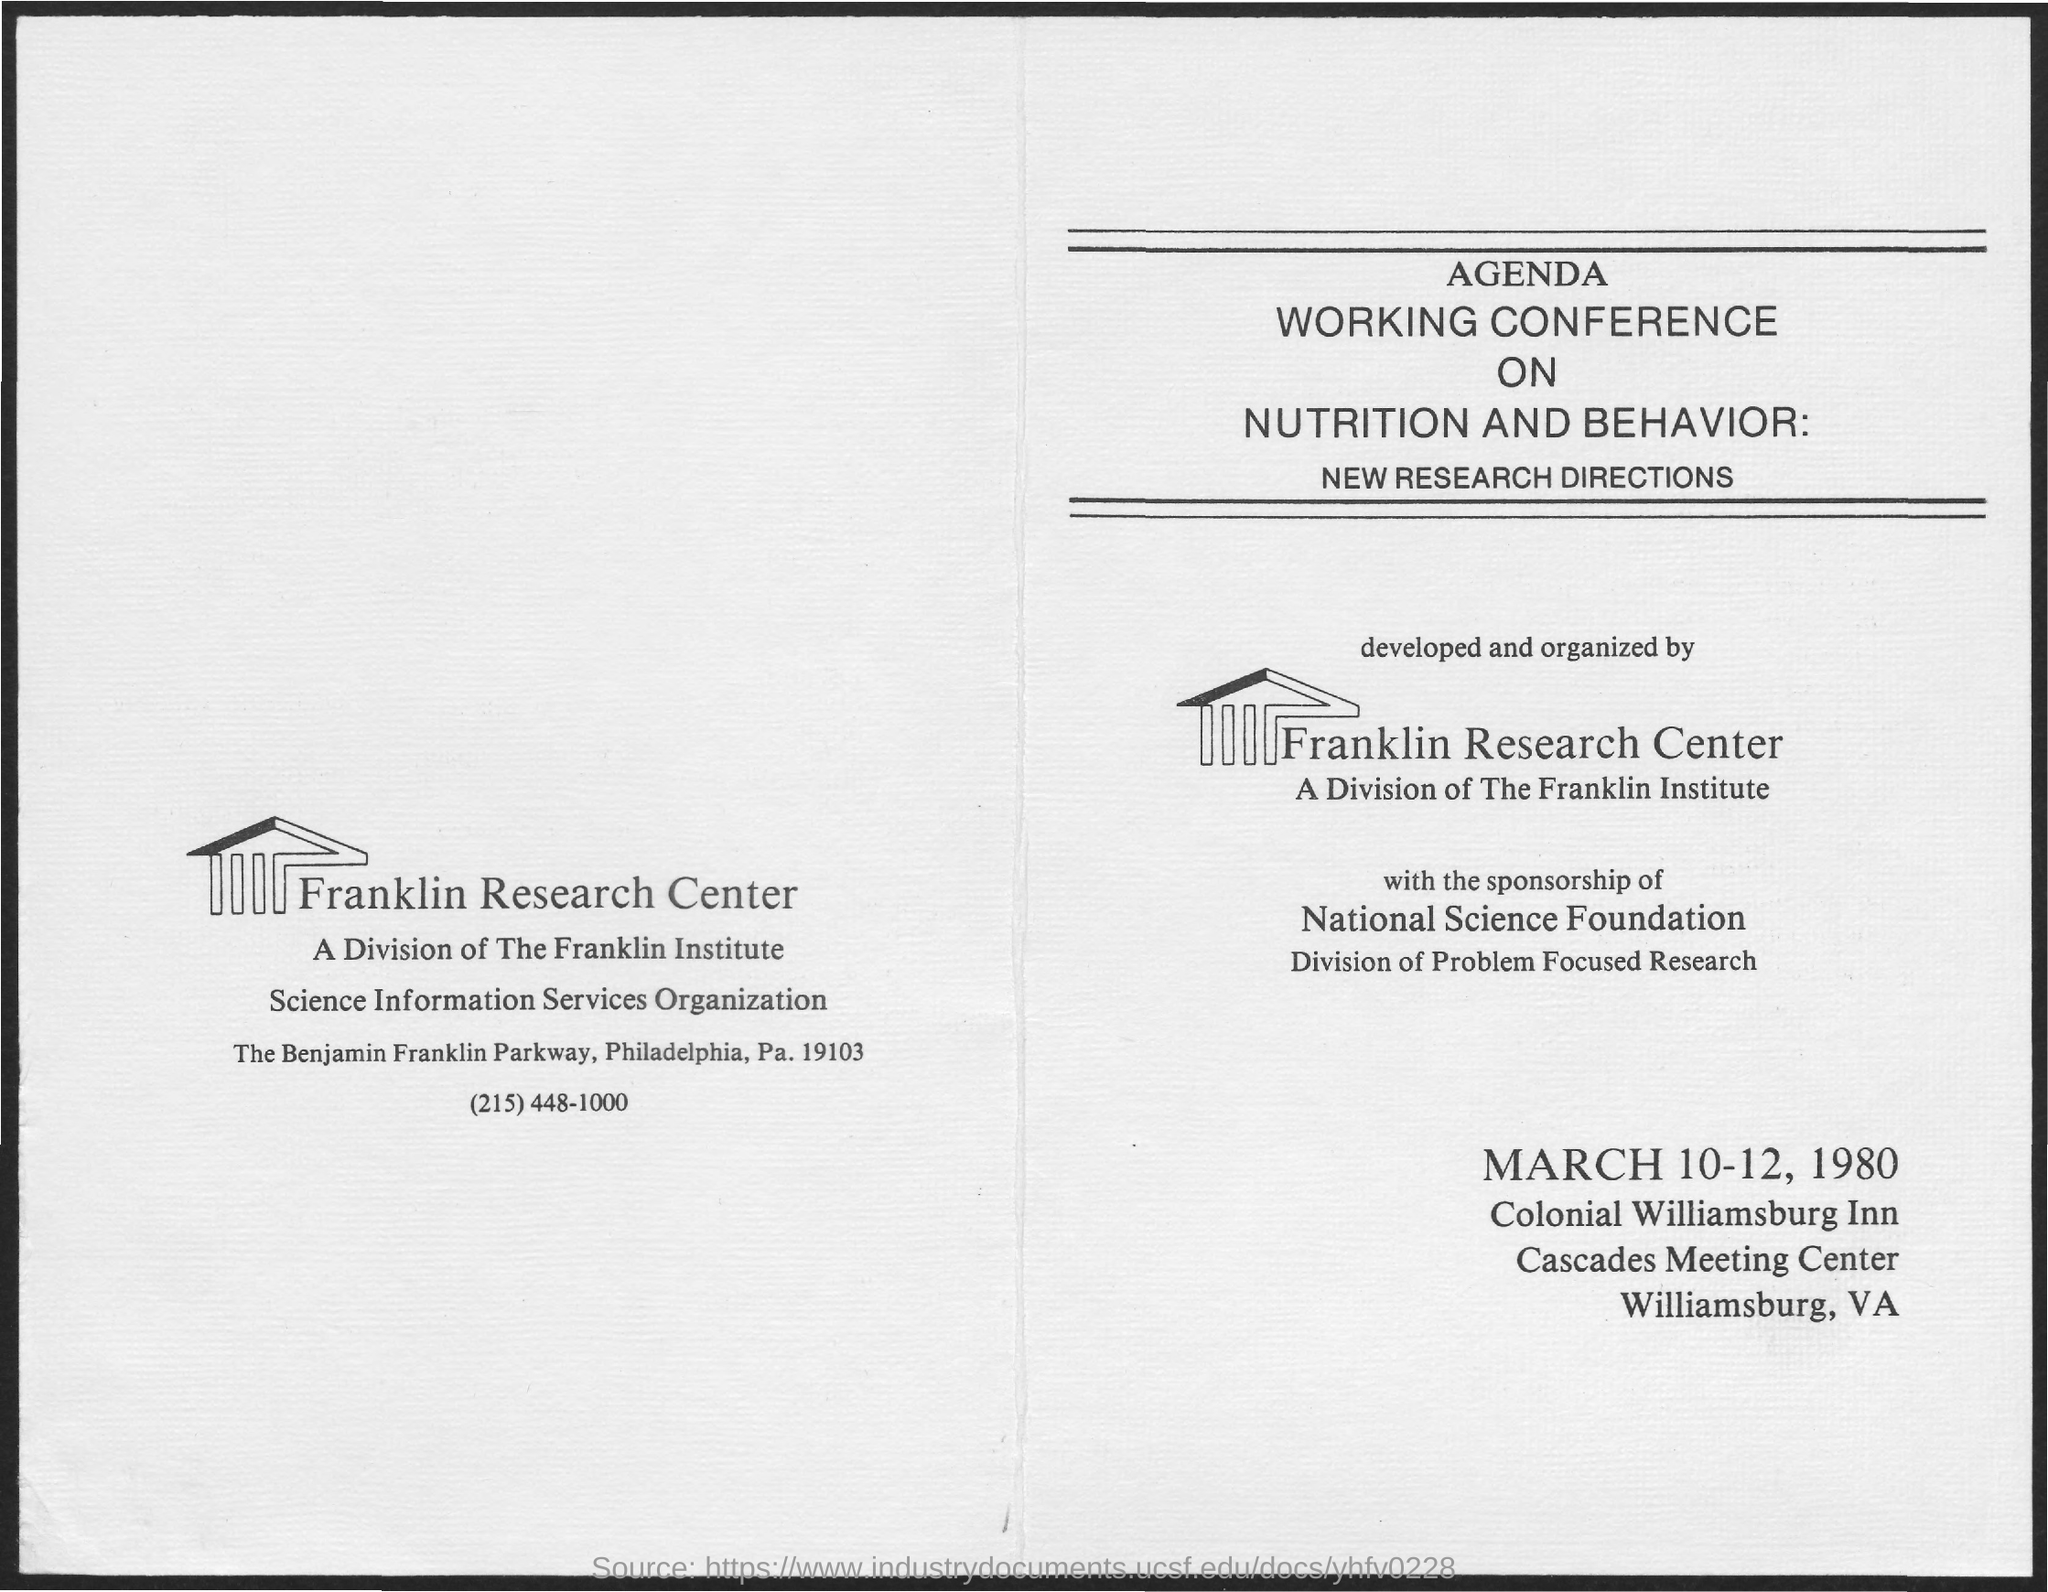What is the name of the research center?
Give a very brief answer. Franklin Research Center. What is the date mentioned at the bottom?
Offer a very short reply. MARCH 10-12, 1980. 